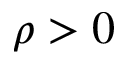Convert formula to latex. <formula><loc_0><loc_0><loc_500><loc_500>\rho > 0</formula> 